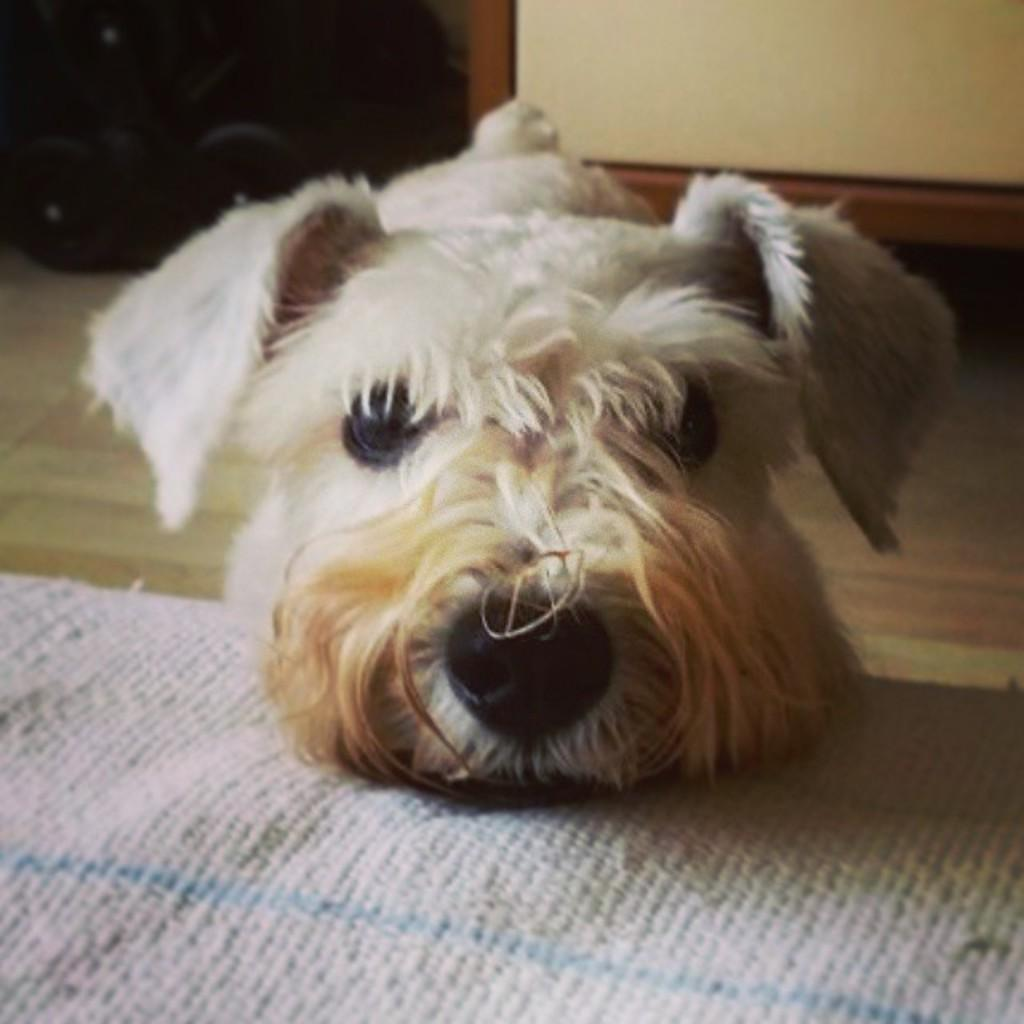What type of animal is present in the image? There is a dog in the image. What is located at the bottom of the image? There is a cloth at the bottom of the image. What can be seen in the background of the image? There appears to be a cupboard in the background of the image. What type of sack is the dog carrying in the image? There is no sack present in the image, and the dog is not carrying anything. 